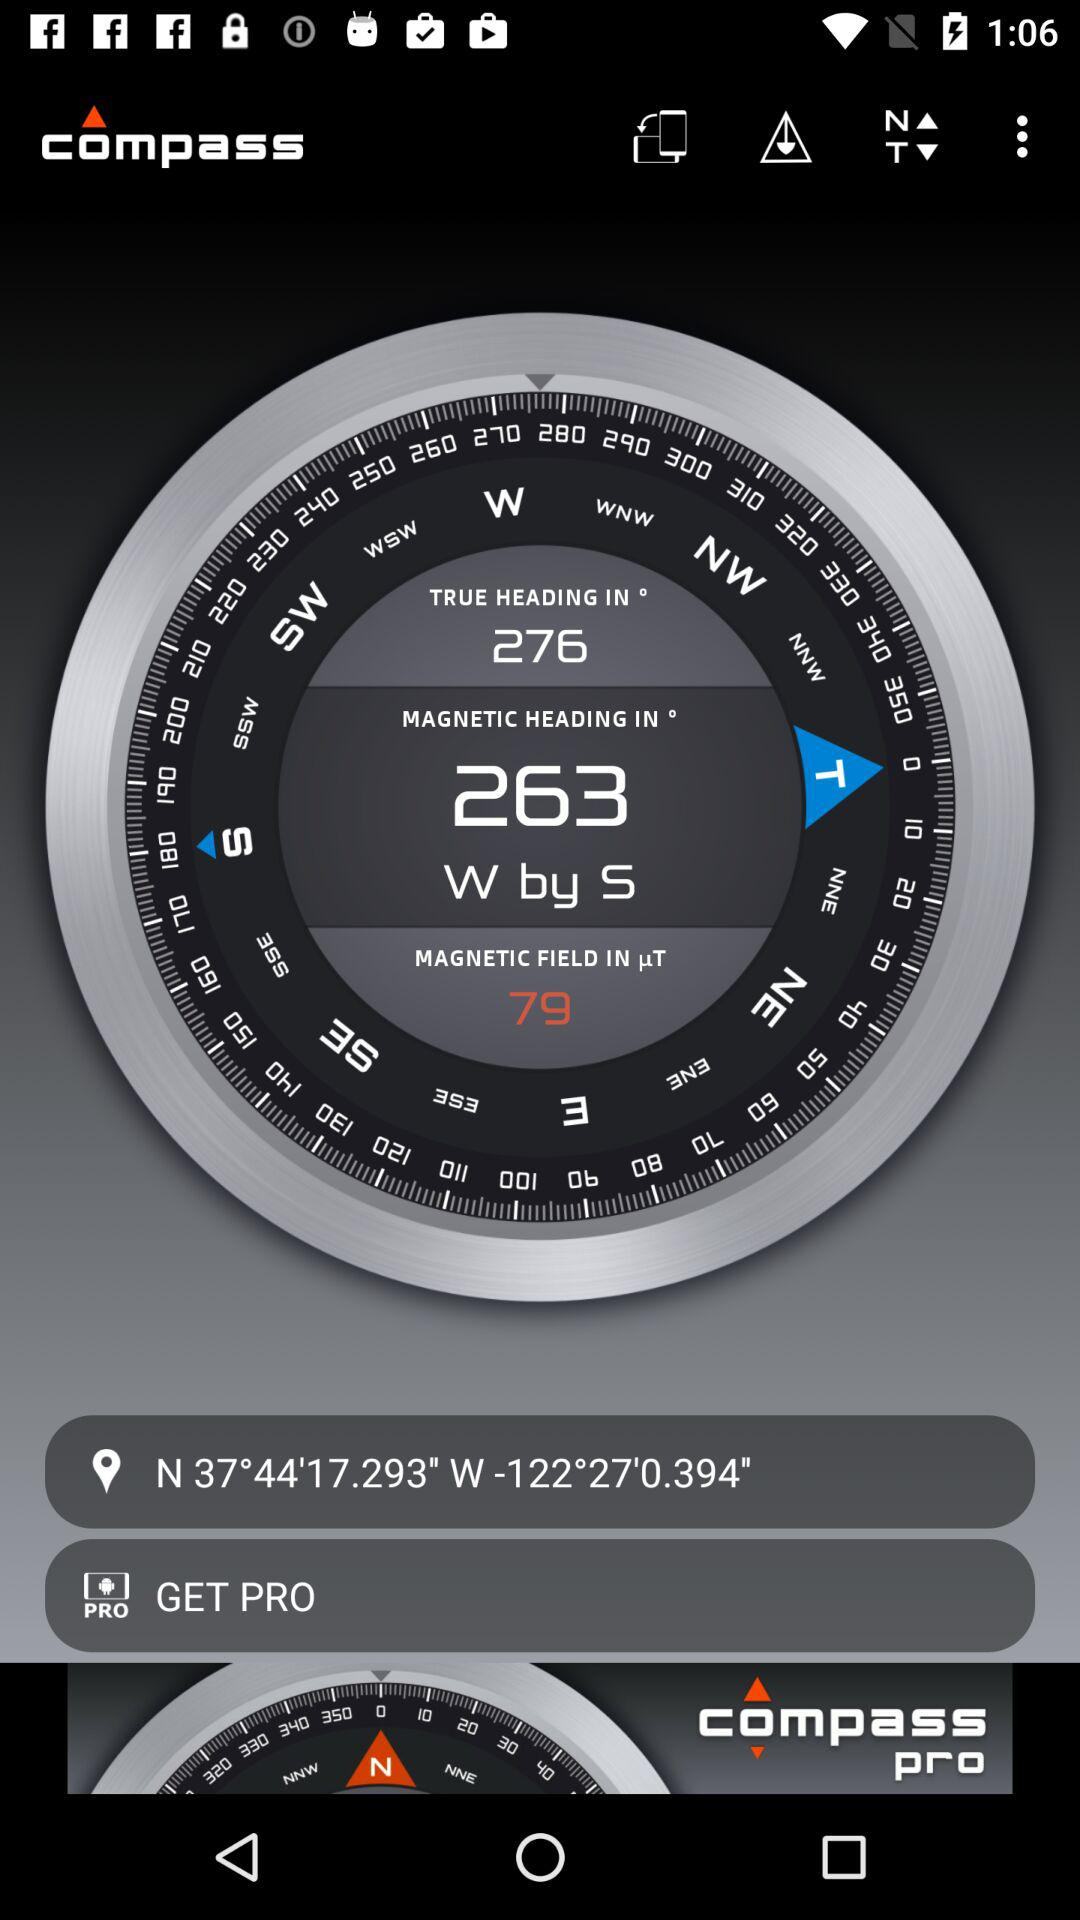What is the longitude? The longitude is -122°27'0.394" W. 